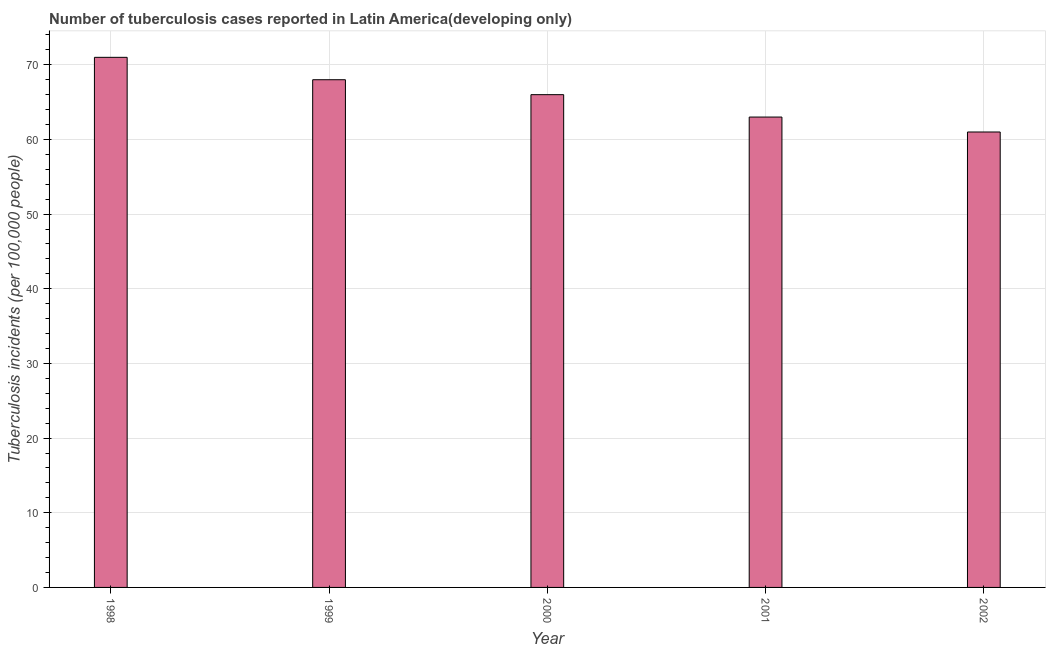Does the graph contain any zero values?
Your answer should be compact. No. What is the title of the graph?
Keep it short and to the point. Number of tuberculosis cases reported in Latin America(developing only). What is the label or title of the X-axis?
Your answer should be compact. Year. What is the label or title of the Y-axis?
Ensure brevity in your answer.  Tuberculosis incidents (per 100,0 people). Across all years, what is the minimum number of tuberculosis incidents?
Your response must be concise. 61. What is the sum of the number of tuberculosis incidents?
Make the answer very short. 329. What is the difference between the number of tuberculosis incidents in 2000 and 2001?
Ensure brevity in your answer.  3. What is the median number of tuberculosis incidents?
Give a very brief answer. 66. What is the ratio of the number of tuberculosis incidents in 2000 to that in 2002?
Ensure brevity in your answer.  1.08. Is the number of tuberculosis incidents in 2000 less than that in 2002?
Offer a terse response. No. What is the difference between the highest and the second highest number of tuberculosis incidents?
Your response must be concise. 3. In how many years, is the number of tuberculosis incidents greater than the average number of tuberculosis incidents taken over all years?
Offer a terse response. 3. How many years are there in the graph?
Your answer should be compact. 5. Are the values on the major ticks of Y-axis written in scientific E-notation?
Your answer should be compact. No. What is the Tuberculosis incidents (per 100,000 people) in 1999?
Provide a short and direct response. 68. What is the difference between the Tuberculosis incidents (per 100,000 people) in 1998 and 1999?
Your answer should be compact. 3. What is the difference between the Tuberculosis incidents (per 100,000 people) in 1998 and 2000?
Offer a very short reply. 5. What is the difference between the Tuberculosis incidents (per 100,000 people) in 1999 and 2000?
Offer a terse response. 2. What is the difference between the Tuberculosis incidents (per 100,000 people) in 1999 and 2001?
Your response must be concise. 5. What is the difference between the Tuberculosis incidents (per 100,000 people) in 1999 and 2002?
Offer a very short reply. 7. What is the difference between the Tuberculosis incidents (per 100,000 people) in 2000 and 2001?
Ensure brevity in your answer.  3. What is the ratio of the Tuberculosis incidents (per 100,000 people) in 1998 to that in 1999?
Your response must be concise. 1.04. What is the ratio of the Tuberculosis incidents (per 100,000 people) in 1998 to that in 2000?
Give a very brief answer. 1.08. What is the ratio of the Tuberculosis incidents (per 100,000 people) in 1998 to that in 2001?
Provide a succinct answer. 1.13. What is the ratio of the Tuberculosis incidents (per 100,000 people) in 1998 to that in 2002?
Give a very brief answer. 1.16. What is the ratio of the Tuberculosis incidents (per 100,000 people) in 1999 to that in 2000?
Keep it short and to the point. 1.03. What is the ratio of the Tuberculosis incidents (per 100,000 people) in 1999 to that in 2001?
Give a very brief answer. 1.08. What is the ratio of the Tuberculosis incidents (per 100,000 people) in 1999 to that in 2002?
Provide a short and direct response. 1.11. What is the ratio of the Tuberculosis incidents (per 100,000 people) in 2000 to that in 2001?
Offer a terse response. 1.05. What is the ratio of the Tuberculosis incidents (per 100,000 people) in 2000 to that in 2002?
Provide a succinct answer. 1.08. What is the ratio of the Tuberculosis incidents (per 100,000 people) in 2001 to that in 2002?
Give a very brief answer. 1.03. 